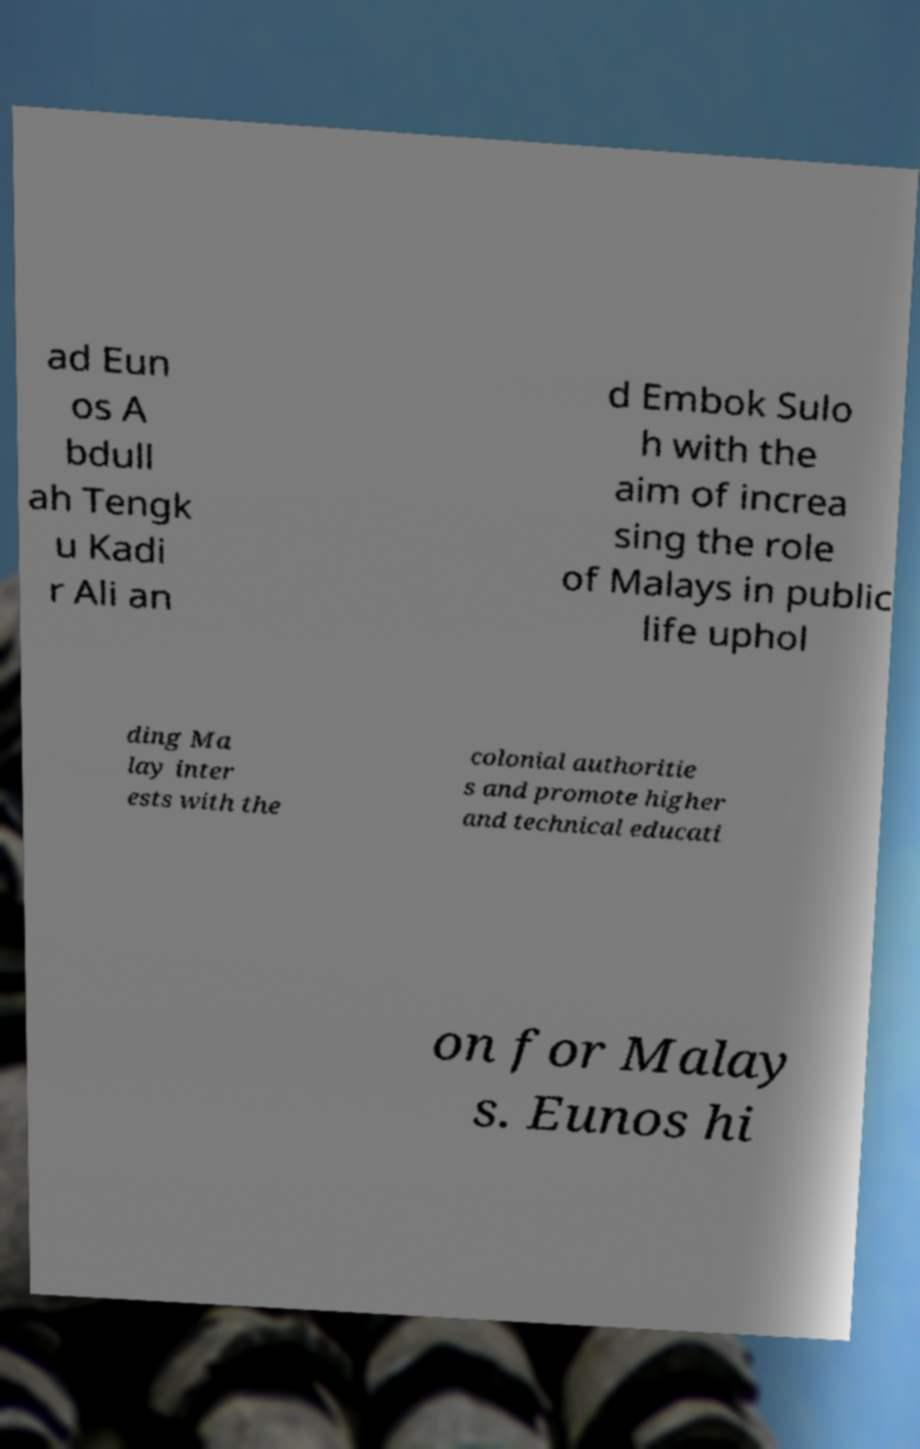For documentation purposes, I need the text within this image transcribed. Could you provide that? ad Eun os A bdull ah Tengk u Kadi r Ali an d Embok Sulo h with the aim of increa sing the role of Malays in public life uphol ding Ma lay inter ests with the colonial authoritie s and promote higher and technical educati on for Malay s. Eunos hi 